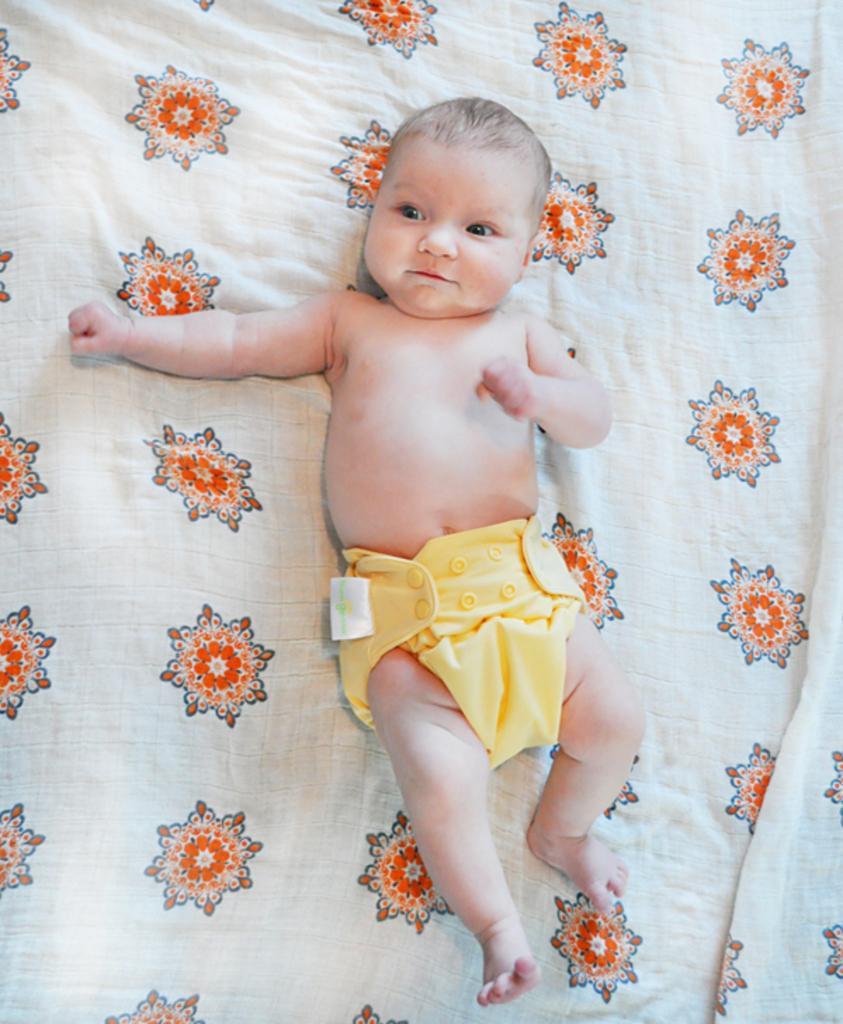How would you summarize this image in a sentence or two? Here I can see a baby is laying on the bed. 